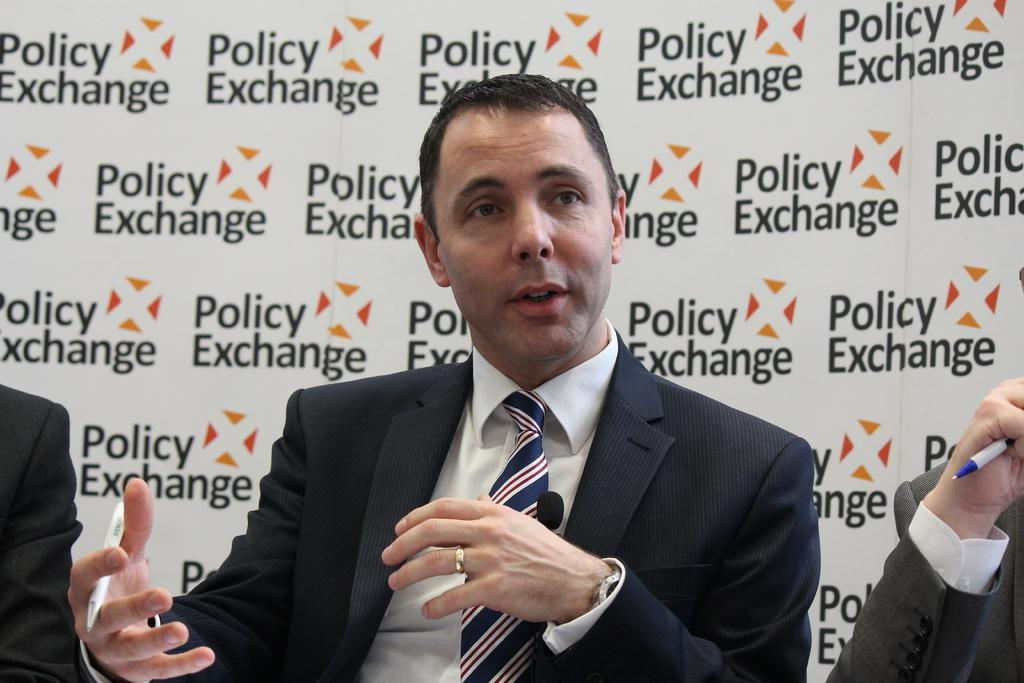How many people are in the image? There are three people in the image. What is the man wearing in the image? One man is wearing a blazer and tie. What is the man holding in his hand? The man is holding a pen in his hand. What can be seen in the background of the image? There is a banner visible in the background of the image. What type of punishment is being administered to the people in the image? There is no indication of punishment in the image; it simply shows three people, one of whom is wearing a blazer and tie and holding a pen. What class are the people in the image attending? There is no indication of a class or educational setting in the image. 